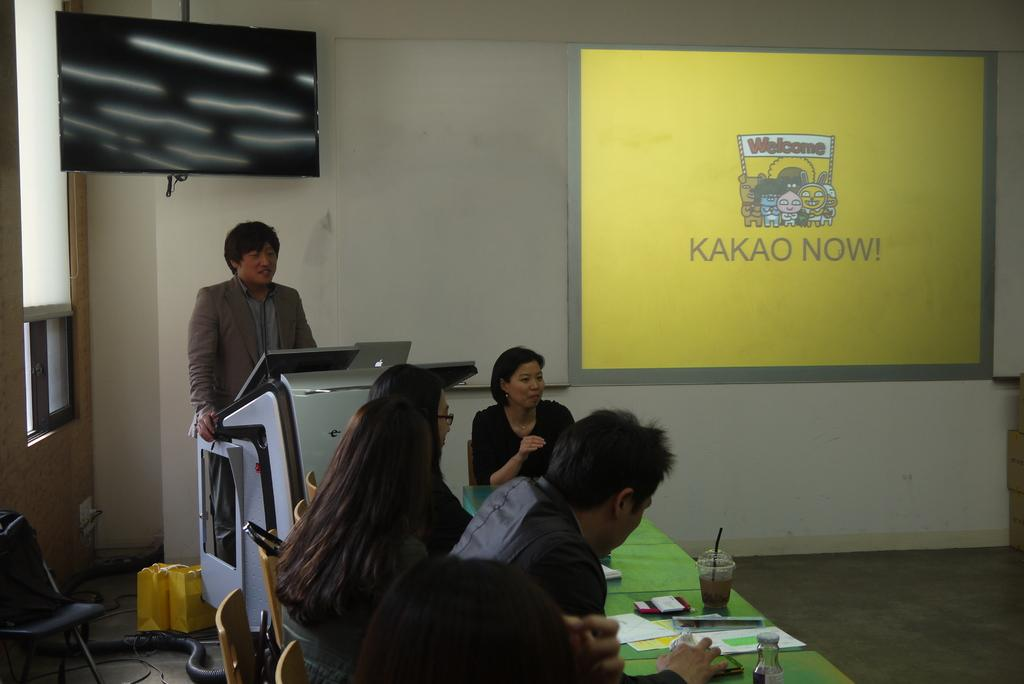Provide a one-sentence caption for the provided image. A group of people sit at a green covered table looking at a presentation for KAKAO NOW!. 